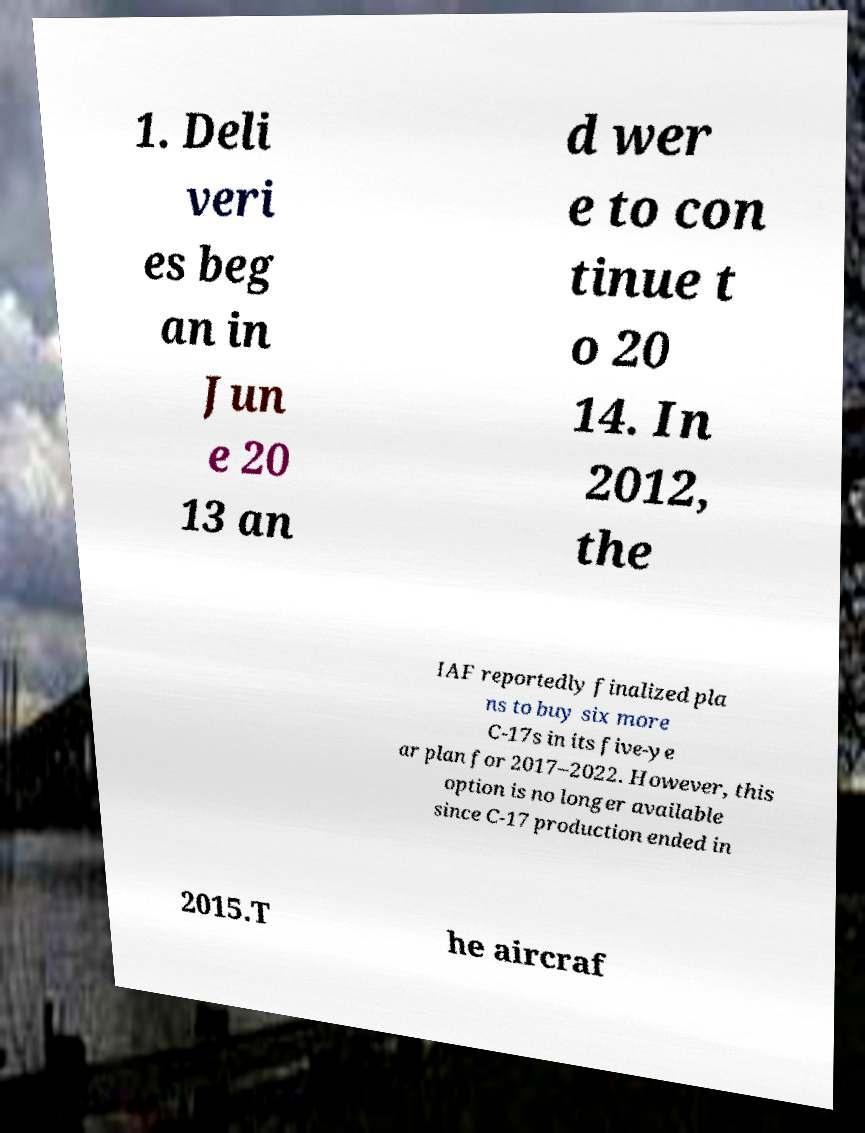What messages or text are displayed in this image? I need them in a readable, typed format. 1. Deli veri es beg an in Jun e 20 13 an d wer e to con tinue t o 20 14. In 2012, the IAF reportedly finalized pla ns to buy six more C-17s in its five-ye ar plan for 2017–2022. However, this option is no longer available since C-17 production ended in 2015.T he aircraf 